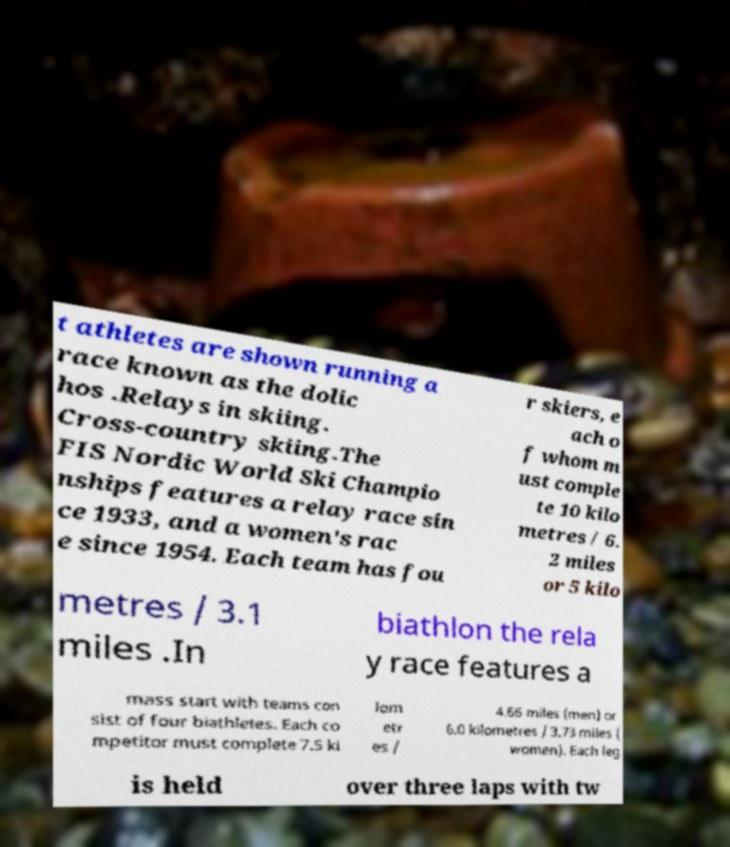Please identify and transcribe the text found in this image. t athletes are shown running a race known as the dolic hos .Relays in skiing. Cross-country skiing.The FIS Nordic World Ski Champio nships features a relay race sin ce 1933, and a women's rac e since 1954. Each team has fou r skiers, e ach o f whom m ust comple te 10 kilo metres / 6. 2 miles or 5 kilo metres / 3.1 miles .In biathlon the rela y race features a mass start with teams con sist of four biathletes. Each co mpetitor must complete 7.5 ki lom etr es / 4.66 miles (men) or 6.0 kilometres / 3.73 miles ( women). Each leg is held over three laps with tw 